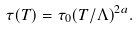<formula> <loc_0><loc_0><loc_500><loc_500>\tau ( T ) = \tau _ { 0 } ( T / \Lambda ) ^ { 2 a } .</formula> 